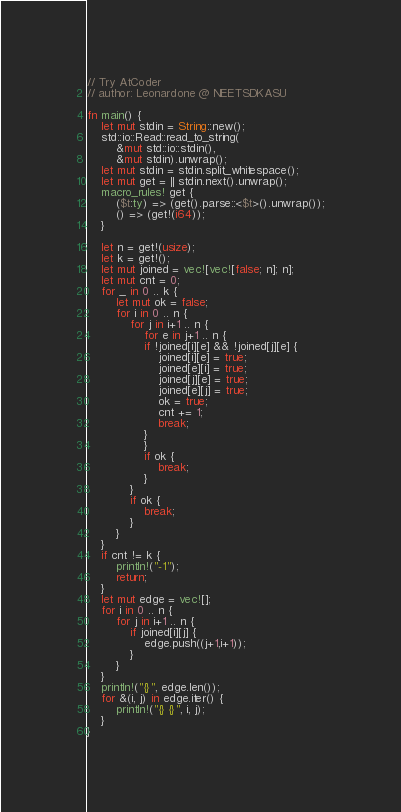Convert code to text. <code><loc_0><loc_0><loc_500><loc_500><_Rust_>// Try AtCoder
// author: Leonardone @ NEETSDKASU

fn main() {
    let mut stdin = String::new();
    std::io::Read::read_to_string(
        &mut std::io::stdin(),
        &mut stdin).unwrap();
    let mut stdin = stdin.split_whitespace();
    let mut get = || stdin.next().unwrap();
    macro_rules! get {
        ($t:ty) => (get().parse::<$t>().unwrap());
        () => (get!(i64));
    }
    
    let n = get!(usize);
    let k = get!();
    let mut joined = vec![vec![false; n]; n];
    let mut cnt = 0;
    for _ in 0 .. k {
        let mut ok = false;
        for i in 0 .. n {
            for j in i+1 .. n {
                for e in j+1 .. n {
                if !joined[i][e] && !joined[j][e] {
                    joined[i][e] = true;
                    joined[e][i] = true;
                    joined[j][e] = true;
                    joined[e][j] = true;
                    ok = true;
                    cnt += 1;
                    break;
                }
                }
                if ok {
                    break;
                }
            }
            if ok {
                break;
            }
        }
    }
    if cnt != k {
        println!("-1");
        return;
    }
    let mut edge = vec![];
    for i in 0 .. n {
        for j in i+1 .. n {
            if joined[i][j] {
                edge.push((j+1,i+1));
            }
        }
    }
    println!("{}", edge.len());
    for &(i, j) in edge.iter() {
        println!("{} {}", i, j);
    }
}</code> 